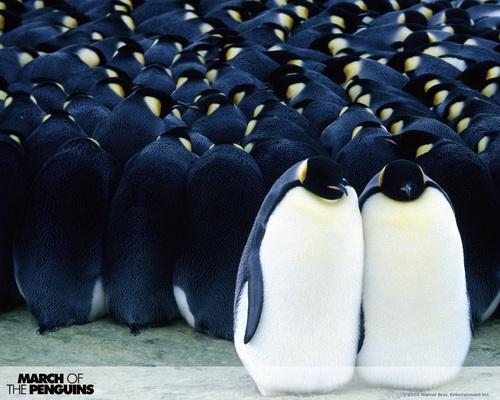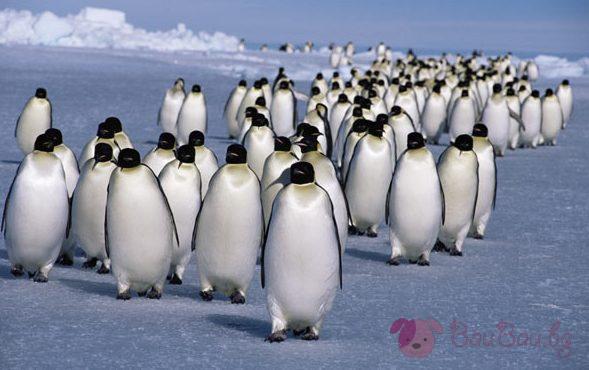The first image is the image on the left, the second image is the image on the right. Examine the images to the left and right. Is the description "In the left image, there are two adult penguins and one baby penguin" accurate? Answer yes or no. No. The first image is the image on the left, the second image is the image on the right. For the images shown, is this caption "One image shows only one penguin family, with parents flanking a baby." true? Answer yes or no. No. 